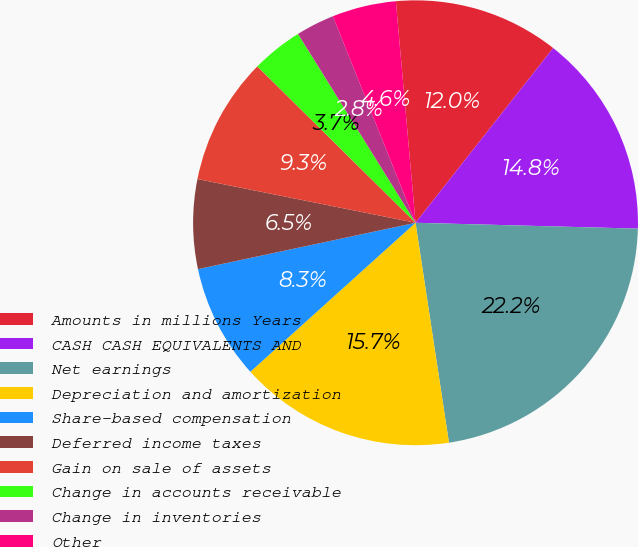Convert chart. <chart><loc_0><loc_0><loc_500><loc_500><pie_chart><fcel>Amounts in millions Years<fcel>CASH CASH EQUIVALENTS AND<fcel>Net earnings<fcel>Depreciation and amortization<fcel>Share-based compensation<fcel>Deferred income taxes<fcel>Gain on sale of assets<fcel>Change in accounts receivable<fcel>Change in inventories<fcel>Other<nl><fcel>12.03%<fcel>14.8%<fcel>22.18%<fcel>15.72%<fcel>8.34%<fcel>6.49%<fcel>9.26%<fcel>3.73%<fcel>2.8%<fcel>4.65%<nl></chart> 